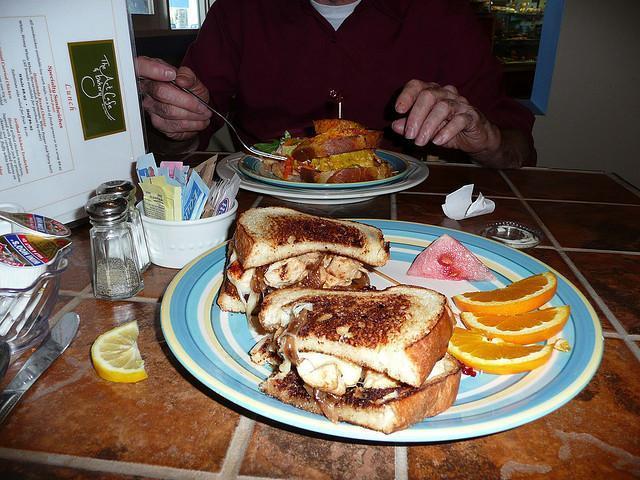How many orange slices are there?
Give a very brief answer. 3. How many oranges are in the photo?
Give a very brief answer. 4. How many sandwiches can you see?
Give a very brief answer. 3. How many bowls are there?
Give a very brief answer. 2. 